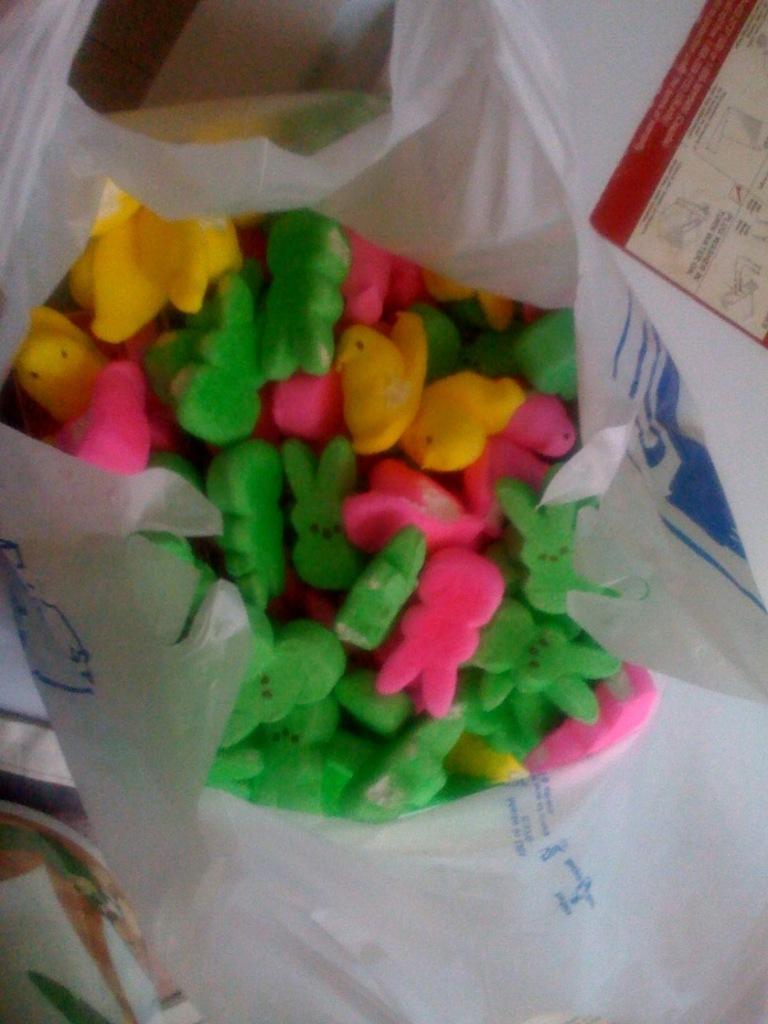Could you give a brief overview of what you see in this image? In the image we can see there is a plastic cover in which the erasers are kept which are in shape of rabbit and duck. The rabbit shaped erasers are in green and pink colour where as the duck shaped erasers are only in yellow colour. 